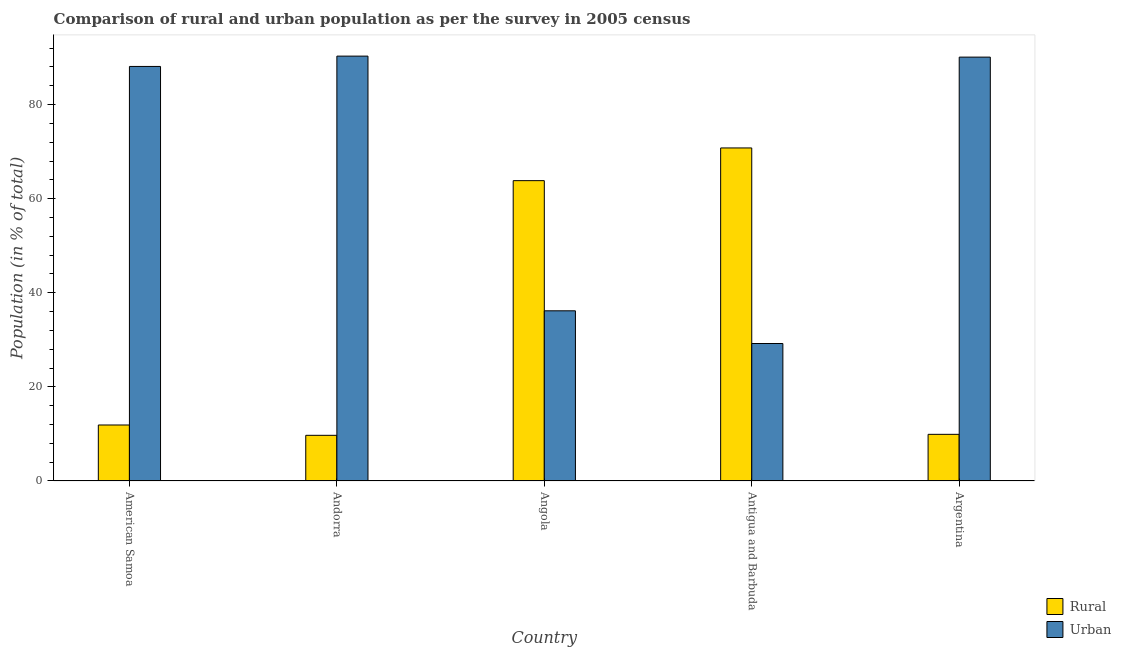Are the number of bars per tick equal to the number of legend labels?
Your answer should be very brief. Yes. Are the number of bars on each tick of the X-axis equal?
Give a very brief answer. Yes. How many bars are there on the 5th tick from the right?
Your answer should be very brief. 2. What is the label of the 5th group of bars from the left?
Provide a succinct answer. Argentina. What is the urban population in Andorra?
Offer a terse response. 90.3. Across all countries, what is the maximum urban population?
Make the answer very short. 90.3. Across all countries, what is the minimum rural population?
Offer a terse response. 9.71. In which country was the urban population maximum?
Offer a terse response. Andorra. In which country was the urban population minimum?
Provide a short and direct response. Antigua and Barbuda. What is the total rural population in the graph?
Your answer should be very brief. 166.13. What is the difference between the rural population in American Samoa and that in Argentina?
Give a very brief answer. 1.98. What is the difference between the rural population in Angola and the urban population in Antigua and Barbuda?
Your answer should be very brief. 34.61. What is the average urban population per country?
Offer a very short reply. 66.77. What is the difference between the rural population and urban population in Antigua and Barbuda?
Keep it short and to the point. 41.56. In how many countries, is the urban population greater than 56 %?
Ensure brevity in your answer.  3. What is the ratio of the rural population in Andorra to that in Antigua and Barbuda?
Provide a succinct answer. 0.14. Is the difference between the rural population in Andorra and Angola greater than the difference between the urban population in Andorra and Angola?
Offer a terse response. No. What is the difference between the highest and the second highest rural population?
Ensure brevity in your answer.  6.95. What is the difference between the highest and the lowest rural population?
Your response must be concise. 61.08. In how many countries, is the rural population greater than the average rural population taken over all countries?
Provide a short and direct response. 2. What does the 1st bar from the left in Andorra represents?
Provide a short and direct response. Rural. What does the 2nd bar from the right in Antigua and Barbuda represents?
Provide a succinct answer. Rural. How many bars are there?
Offer a terse response. 10. Are all the bars in the graph horizontal?
Your answer should be very brief. No. How many countries are there in the graph?
Ensure brevity in your answer.  5. Does the graph contain grids?
Provide a short and direct response. No. How are the legend labels stacked?
Your answer should be compact. Vertical. What is the title of the graph?
Give a very brief answer. Comparison of rural and urban population as per the survey in 2005 census. What is the label or title of the X-axis?
Offer a very short reply. Country. What is the label or title of the Y-axis?
Your answer should be compact. Population (in % of total). What is the Population (in % of total) of Urban in American Samoa?
Provide a succinct answer. 88.1. What is the Population (in % of total) of Rural in Andorra?
Your response must be concise. 9.71. What is the Population (in % of total) in Urban in Andorra?
Offer a terse response. 90.3. What is the Population (in % of total) of Rural in Angola?
Make the answer very short. 63.83. What is the Population (in % of total) of Urban in Angola?
Your answer should be very brief. 36.17. What is the Population (in % of total) of Rural in Antigua and Barbuda?
Your answer should be compact. 70.78. What is the Population (in % of total) in Urban in Antigua and Barbuda?
Your answer should be very brief. 29.22. What is the Population (in % of total) of Rural in Argentina?
Provide a succinct answer. 9.92. What is the Population (in % of total) of Urban in Argentina?
Offer a terse response. 90.08. Across all countries, what is the maximum Population (in % of total) in Rural?
Provide a short and direct response. 70.78. Across all countries, what is the maximum Population (in % of total) in Urban?
Provide a short and direct response. 90.3. Across all countries, what is the minimum Population (in % of total) in Rural?
Keep it short and to the point. 9.71. Across all countries, what is the minimum Population (in % of total) of Urban?
Make the answer very short. 29.22. What is the total Population (in % of total) of Rural in the graph?
Give a very brief answer. 166.13. What is the total Population (in % of total) in Urban in the graph?
Provide a short and direct response. 333.87. What is the difference between the Population (in % of total) of Rural in American Samoa and that in Andorra?
Your response must be concise. 2.19. What is the difference between the Population (in % of total) in Urban in American Samoa and that in Andorra?
Offer a very short reply. -2.19. What is the difference between the Population (in % of total) in Rural in American Samoa and that in Angola?
Your answer should be very brief. -51.93. What is the difference between the Population (in % of total) of Urban in American Samoa and that in Angola?
Offer a very short reply. 51.93. What is the difference between the Population (in % of total) of Rural in American Samoa and that in Antigua and Barbuda?
Give a very brief answer. -58.88. What is the difference between the Population (in % of total) of Urban in American Samoa and that in Antigua and Barbuda?
Provide a succinct answer. 58.88. What is the difference between the Population (in % of total) of Rural in American Samoa and that in Argentina?
Your answer should be very brief. 1.98. What is the difference between the Population (in % of total) of Urban in American Samoa and that in Argentina?
Offer a very short reply. -1.98. What is the difference between the Population (in % of total) in Rural in Andorra and that in Angola?
Your response must be concise. -54.13. What is the difference between the Population (in % of total) in Urban in Andorra and that in Angola?
Provide a succinct answer. 54.13. What is the difference between the Population (in % of total) in Rural in Andorra and that in Antigua and Barbuda?
Ensure brevity in your answer.  -61.08. What is the difference between the Population (in % of total) of Urban in Andorra and that in Antigua and Barbuda?
Your response must be concise. 61.08. What is the difference between the Population (in % of total) of Rural in Andorra and that in Argentina?
Provide a short and direct response. -0.21. What is the difference between the Population (in % of total) in Urban in Andorra and that in Argentina?
Give a very brief answer. 0.21. What is the difference between the Population (in % of total) in Rural in Angola and that in Antigua and Barbuda?
Give a very brief answer. -6.95. What is the difference between the Population (in % of total) in Urban in Angola and that in Antigua and Barbuda?
Offer a terse response. 6.95. What is the difference between the Population (in % of total) of Rural in Angola and that in Argentina?
Provide a short and direct response. 53.91. What is the difference between the Population (in % of total) of Urban in Angola and that in Argentina?
Ensure brevity in your answer.  -53.91. What is the difference between the Population (in % of total) in Rural in Antigua and Barbuda and that in Argentina?
Offer a very short reply. 60.87. What is the difference between the Population (in % of total) in Urban in Antigua and Barbuda and that in Argentina?
Your answer should be very brief. -60.87. What is the difference between the Population (in % of total) in Rural in American Samoa and the Population (in % of total) in Urban in Andorra?
Provide a succinct answer. -78.39. What is the difference between the Population (in % of total) in Rural in American Samoa and the Population (in % of total) in Urban in Angola?
Keep it short and to the point. -24.27. What is the difference between the Population (in % of total) of Rural in American Samoa and the Population (in % of total) of Urban in Antigua and Barbuda?
Offer a terse response. -17.32. What is the difference between the Population (in % of total) in Rural in American Samoa and the Population (in % of total) in Urban in Argentina?
Your response must be concise. -78.18. What is the difference between the Population (in % of total) of Rural in Andorra and the Population (in % of total) of Urban in Angola?
Your answer should be very brief. -26.46. What is the difference between the Population (in % of total) of Rural in Andorra and the Population (in % of total) of Urban in Antigua and Barbuda?
Your answer should be very brief. -19.51. What is the difference between the Population (in % of total) of Rural in Andorra and the Population (in % of total) of Urban in Argentina?
Your answer should be very brief. -80.38. What is the difference between the Population (in % of total) of Rural in Angola and the Population (in % of total) of Urban in Antigua and Barbuda?
Your answer should be compact. 34.61. What is the difference between the Population (in % of total) of Rural in Angola and the Population (in % of total) of Urban in Argentina?
Offer a very short reply. -26.25. What is the difference between the Population (in % of total) of Rural in Antigua and Barbuda and the Population (in % of total) of Urban in Argentina?
Keep it short and to the point. -19.3. What is the average Population (in % of total) in Rural per country?
Offer a terse response. 33.23. What is the average Population (in % of total) of Urban per country?
Give a very brief answer. 66.77. What is the difference between the Population (in % of total) in Rural and Population (in % of total) in Urban in American Samoa?
Keep it short and to the point. -76.2. What is the difference between the Population (in % of total) in Rural and Population (in % of total) in Urban in Andorra?
Ensure brevity in your answer.  -80.59. What is the difference between the Population (in % of total) of Rural and Population (in % of total) of Urban in Angola?
Your answer should be compact. 27.66. What is the difference between the Population (in % of total) of Rural and Population (in % of total) of Urban in Antigua and Barbuda?
Your answer should be very brief. 41.56. What is the difference between the Population (in % of total) in Rural and Population (in % of total) in Urban in Argentina?
Keep it short and to the point. -80.17. What is the ratio of the Population (in % of total) in Rural in American Samoa to that in Andorra?
Your answer should be compact. 1.23. What is the ratio of the Population (in % of total) of Urban in American Samoa to that in Andorra?
Your answer should be very brief. 0.98. What is the ratio of the Population (in % of total) in Rural in American Samoa to that in Angola?
Provide a short and direct response. 0.19. What is the ratio of the Population (in % of total) of Urban in American Samoa to that in Angola?
Your answer should be very brief. 2.44. What is the ratio of the Population (in % of total) in Rural in American Samoa to that in Antigua and Barbuda?
Keep it short and to the point. 0.17. What is the ratio of the Population (in % of total) of Urban in American Samoa to that in Antigua and Barbuda?
Make the answer very short. 3.02. What is the ratio of the Population (in % of total) of Rural in American Samoa to that in Argentina?
Offer a very short reply. 1.2. What is the ratio of the Population (in % of total) in Rural in Andorra to that in Angola?
Make the answer very short. 0.15. What is the ratio of the Population (in % of total) in Urban in Andorra to that in Angola?
Your answer should be compact. 2.5. What is the ratio of the Population (in % of total) in Rural in Andorra to that in Antigua and Barbuda?
Make the answer very short. 0.14. What is the ratio of the Population (in % of total) of Urban in Andorra to that in Antigua and Barbuda?
Provide a short and direct response. 3.09. What is the ratio of the Population (in % of total) in Rural in Andorra to that in Argentina?
Provide a short and direct response. 0.98. What is the ratio of the Population (in % of total) of Rural in Angola to that in Antigua and Barbuda?
Provide a short and direct response. 0.9. What is the ratio of the Population (in % of total) in Urban in Angola to that in Antigua and Barbuda?
Offer a terse response. 1.24. What is the ratio of the Population (in % of total) in Rural in Angola to that in Argentina?
Offer a terse response. 6.44. What is the ratio of the Population (in % of total) in Urban in Angola to that in Argentina?
Ensure brevity in your answer.  0.4. What is the ratio of the Population (in % of total) of Rural in Antigua and Barbuda to that in Argentina?
Ensure brevity in your answer.  7.14. What is the ratio of the Population (in % of total) of Urban in Antigua and Barbuda to that in Argentina?
Your response must be concise. 0.32. What is the difference between the highest and the second highest Population (in % of total) in Rural?
Ensure brevity in your answer.  6.95. What is the difference between the highest and the second highest Population (in % of total) in Urban?
Keep it short and to the point. 0.21. What is the difference between the highest and the lowest Population (in % of total) of Rural?
Offer a very short reply. 61.08. What is the difference between the highest and the lowest Population (in % of total) in Urban?
Offer a terse response. 61.08. 